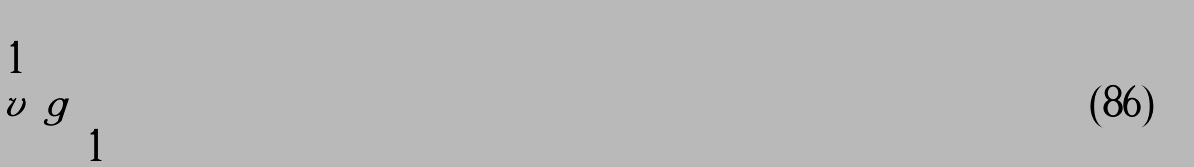Convert formula to latex. <formula><loc_0><loc_0><loc_500><loc_500>\begin{pmatrix} 1 & & \\ v & g & \\ & & 1 \end{pmatrix}</formula> 